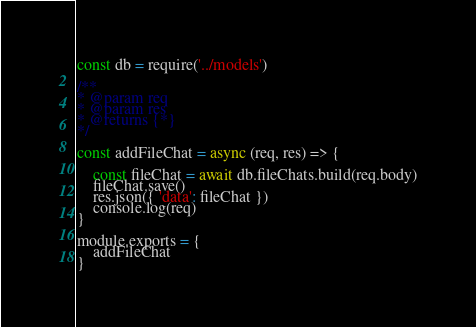<code> <loc_0><loc_0><loc_500><loc_500><_JavaScript_>const db = require('../models')

/**
* @param req
* @param res
* @returns {*}
*/

const addFileChat = async (req, res) => {
    
    const fileChat = await db.fileChats.build(req.body)
    fileChat.save()
    res.json({ 'data': fileChat })
    console.log(req)
}

module.exports = {
    addFileChat
}</code> 